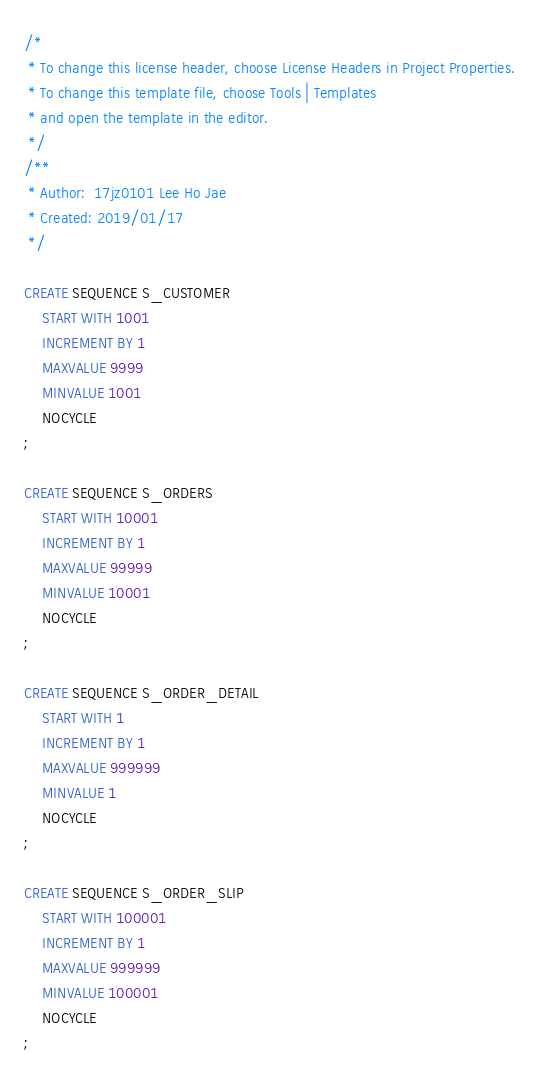Convert code to text. <code><loc_0><loc_0><loc_500><loc_500><_SQL_>/* 
 * To change this license header, choose License Headers in Project Properties.
 * To change this template file, choose Tools | Templates
 * and open the template in the editor.
 */
/**
 * Author:  17jz0101 Lee Ho Jae
 * Created: 2019/01/17
 */

CREATE SEQUENCE S_CUSTOMER
    START WITH 1001
    INCREMENT BY 1
    MAXVALUE 9999
    MINVALUE 1001
    NOCYCLE
;

CREATE SEQUENCE S_ORDERS
    START WITH 10001
    INCREMENT BY 1
    MAXVALUE 99999
    MINVALUE 10001
    NOCYCLE
;

CREATE SEQUENCE S_ORDER_DETAIL
    START WITH 1
    INCREMENT BY 1
    MAXVALUE 999999
    MINVALUE 1
    NOCYCLE
;

CREATE SEQUENCE S_ORDER_SLIP
    START WITH 100001
    INCREMENT BY 1
    MAXVALUE 999999
    MINVALUE 100001
    NOCYCLE
;</code> 